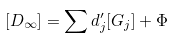Convert formula to latex. <formula><loc_0><loc_0><loc_500><loc_500>[ D _ { \infty } ] = \sum d _ { j } ^ { \prime } [ G _ { j } ] + \Phi</formula> 